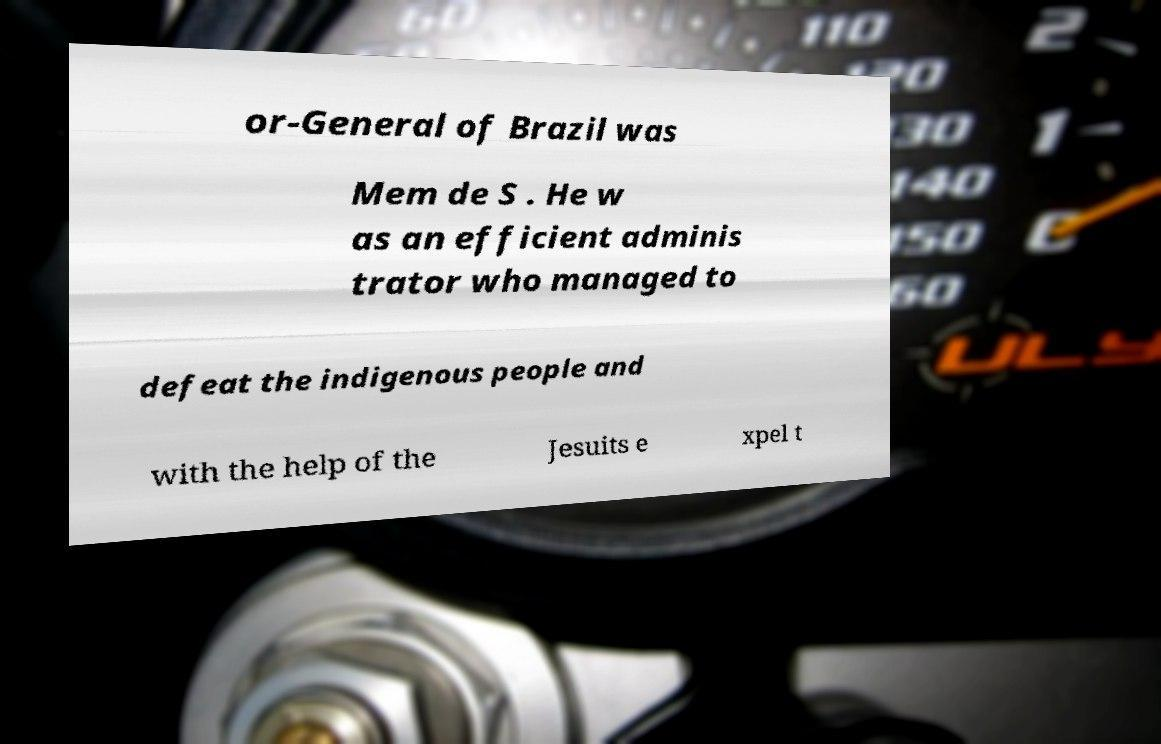Can you accurately transcribe the text from the provided image for me? or-General of Brazil was Mem de S . He w as an efficient adminis trator who managed to defeat the indigenous people and with the help of the Jesuits e xpel t 